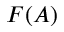<formula> <loc_0><loc_0><loc_500><loc_500>F ( A )</formula> 